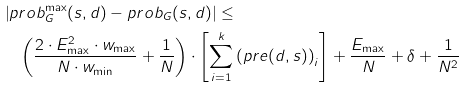Convert formula to latex. <formula><loc_0><loc_0><loc_500><loc_500>& \left | p r o b ^ { \max } _ { G } ( s , d ) - p r o b _ { G } ( s , d ) \right | \leq \\ & \quad \left ( \frac { 2 \cdot E ^ { 2 } _ { \max } \cdot w _ { \max } } { N \cdot w _ { \min } } + \frac { 1 } { N } \right ) \cdot \left [ \sum _ { i = 1 } ^ { k } \left ( p r e ( d , s ) \right ) _ { i } \right ] + \frac { E _ { \max } } { N } + \delta + \frac { 1 } { N ^ { 2 } }</formula> 